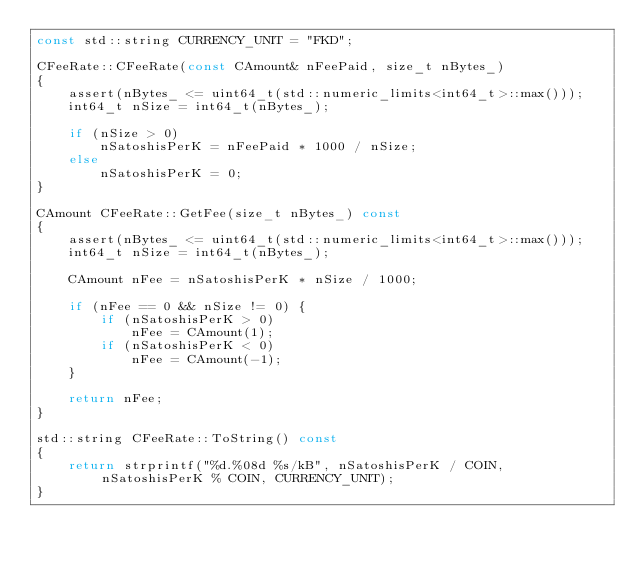<code> <loc_0><loc_0><loc_500><loc_500><_C++_>const std::string CURRENCY_UNIT = "FKD";

CFeeRate::CFeeRate(const CAmount& nFeePaid, size_t nBytes_)
{
    assert(nBytes_ <= uint64_t(std::numeric_limits<int64_t>::max()));
    int64_t nSize = int64_t(nBytes_);

    if (nSize > 0)
        nSatoshisPerK = nFeePaid * 1000 / nSize;
    else
        nSatoshisPerK = 0;
}

CAmount CFeeRate::GetFee(size_t nBytes_) const
{
    assert(nBytes_ <= uint64_t(std::numeric_limits<int64_t>::max()));
    int64_t nSize = int64_t(nBytes_);

    CAmount nFee = nSatoshisPerK * nSize / 1000;

    if (nFee == 0 && nSize != 0) {
        if (nSatoshisPerK > 0)
            nFee = CAmount(1);
        if (nSatoshisPerK < 0)
            nFee = CAmount(-1);
    }

    return nFee;
}

std::string CFeeRate::ToString() const
{
    return strprintf("%d.%08d %s/kB", nSatoshisPerK / COIN, nSatoshisPerK % COIN, CURRENCY_UNIT);
}
</code> 